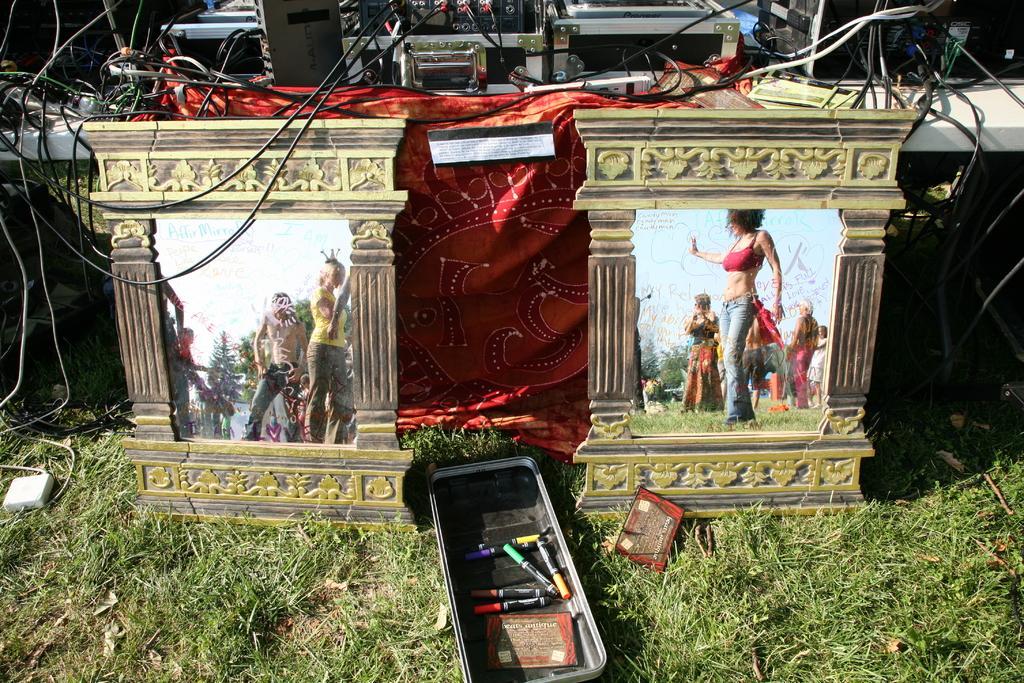Describe this image in one or two sentences. This picture is clicked outside. In the foreground we can see the green grass and a box containing some items is placed on the ground and we can see the two objects which seems to be the picture frames containing the pictures of group of people and the sky and trees. In the background we can see the electronic devices which are placed on the top of the table and we can see the cables and some other items 